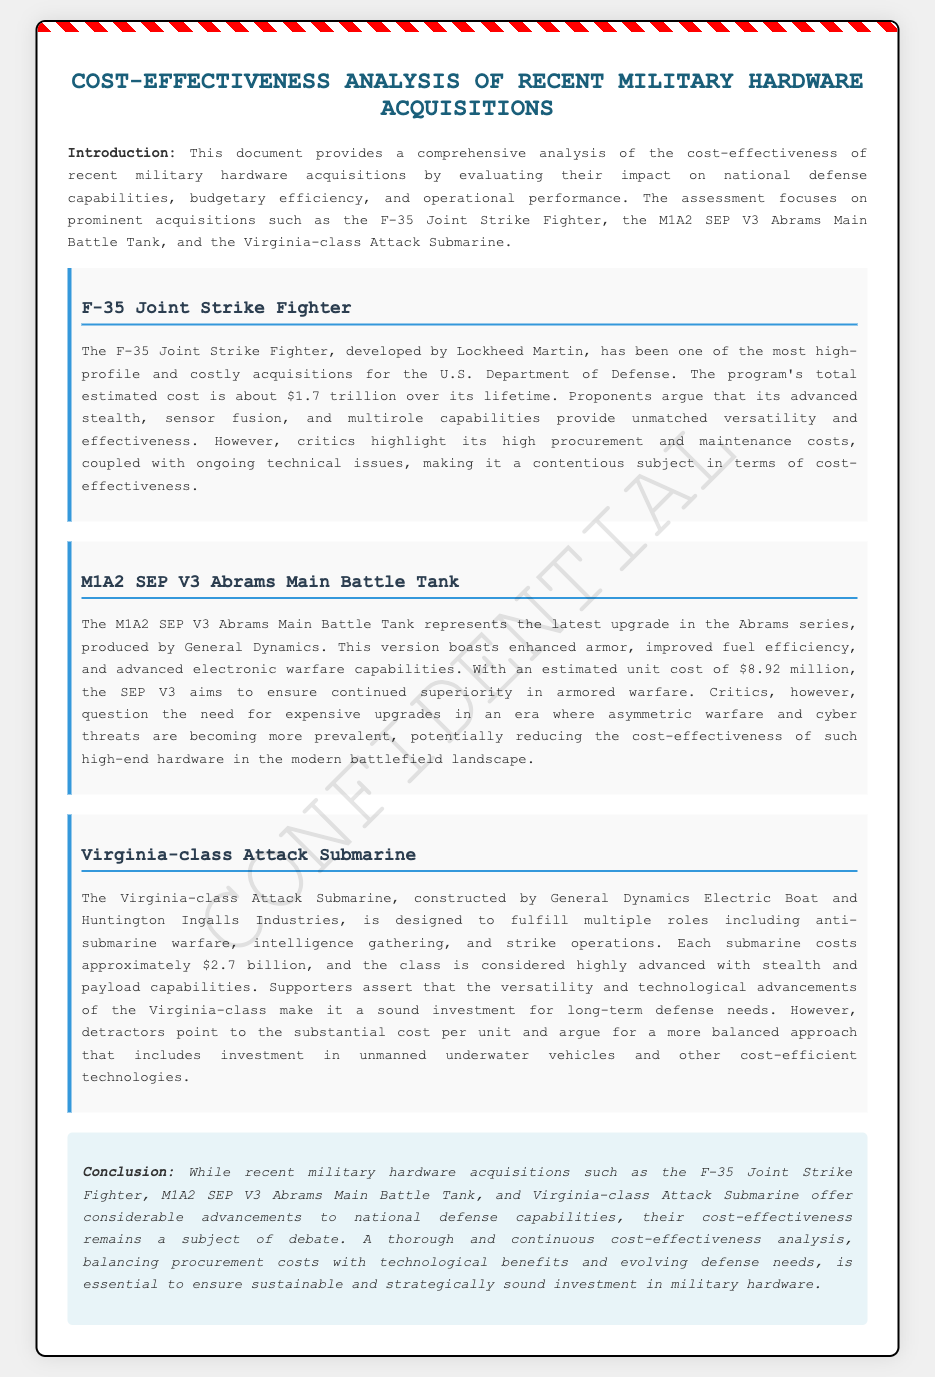What is the total estimated cost of the F-35 program? The total estimated cost of the F-35 Joint Strike Fighter program is mentioned as about $1.7 trillion.
Answer: $1.7 trillion What is the estimated unit cost of the M1A2 SEP V3 Abrams Main Battle Tank? The estimated unit cost of the M1A2 SEP V3 Abrams Main Battle Tank is provided in the document.
Answer: $8.92 million What main roles does the Virginia-class Attack Submarine fulfill? The Virginia-class Attack Submarine is designed to fulfill multiple roles, which include anti-submarine warfare, intelligence gathering, and strike operations.
Answer: anti-submarine warfare, intelligence gathering, and strike operations What is a key argument against the F-35 program? Critics highlight ongoing technical issues, which are a point of contention regarding the F-35.
Answer: high procurement and maintenance costs What is one reason supporters advocate for the Virginia-class Attack Submarine? Supporters assert that the technological advancements of the Virginia-class make it a sound investment for long-term defense needs.
Answer: versatility and technological advancements What is the main issue raised by critics regarding armored warfare upgrades like the M1A2 SEP V3? Critics question the need for expensive upgrades in an era where asymmetric warfare and cyber threats are becoming more prevalent.
Answer: cost-effectiveness in modern battlefield What does the conclusion emphasize regarding military hardware investments? The conclusion emphasizes the necessity for a thorough and continuous cost-effectiveness analysis to ensure sustainable investments.
Answer: sustainable and strategically sound investment What is the primary focus of this document? The primary focus of the document is on the cost-effectiveness of recent military hardware acquisitions and their impact on national defense.
Answer: cost-effectiveness of recent military hardware acquisitions 